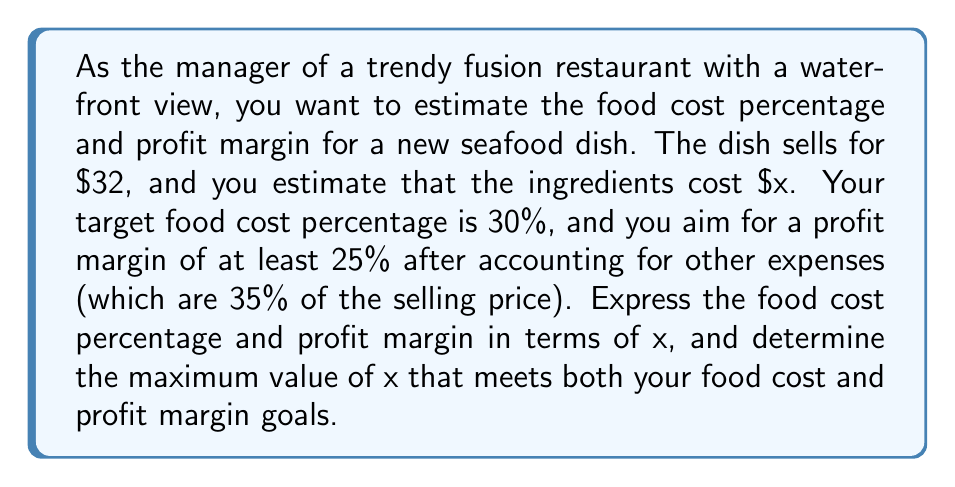Provide a solution to this math problem. Let's break this problem down step by step:

1. Define the variables:
   - Selling price: $32
   - Ingredient cost: $x
   - Other expenses: 35% of selling price = $0.35 * 32 = $11.20

2. Express the food cost percentage in terms of x:
   Food cost percentage = $\frac{\text{Ingredient cost}}{\text{Selling price}} * 100\%$
   $$\text{Food cost percentage} = \frac{x}{32} * 100\% = \frac{25x}{8}\%$$

3. Express the profit margin in terms of x:
   Profit = Selling price - Ingredient cost - Other expenses
   $$\text{Profit} = 32 - x - 11.20 = 20.80 - x$$
   
   Profit margin = $\frac{\text{Profit}}{\text{Selling price}} * 100\%$
   $$\text{Profit margin} = \frac{20.80 - x}{32} * 100\% = (65 - \frac{25x}{8})\%$$

4. Set up inequalities based on the goals:
   For food cost percentage: $\frac{25x}{8} \leq 30$
   For profit margin: $65 - \frac{25x}{8} \geq 25$

5. Solve the inequalities:
   From food cost: $\frac{25x}{8} \leq 30$
                   $25x \leq 240$
                   $x \leq 9.60$

   From profit margin: $65 - \frac{25x}{8} \geq 25$
                       $40 \geq \frac{25x}{8}$
                       $12.80 \geq x$

6. The maximum value of x that satisfies both conditions is the smaller of the two upper bounds: $9.60.

Therefore, the maximum ingredient cost (x) that meets both the food cost percentage and profit margin goals is $9.60.
Answer: The maximum ingredient cost (x) that meets both the 30% food cost percentage and 25% profit margin goals is $9.60. 